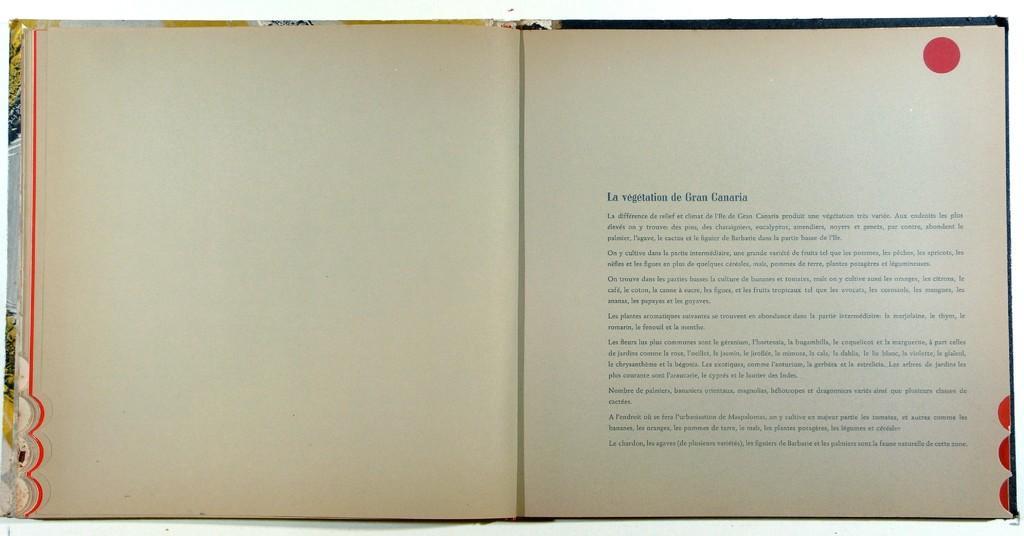Describe this image in one or two sentences. There is a book. On the right side of the book something is written. On the top there is a circle in red color. 